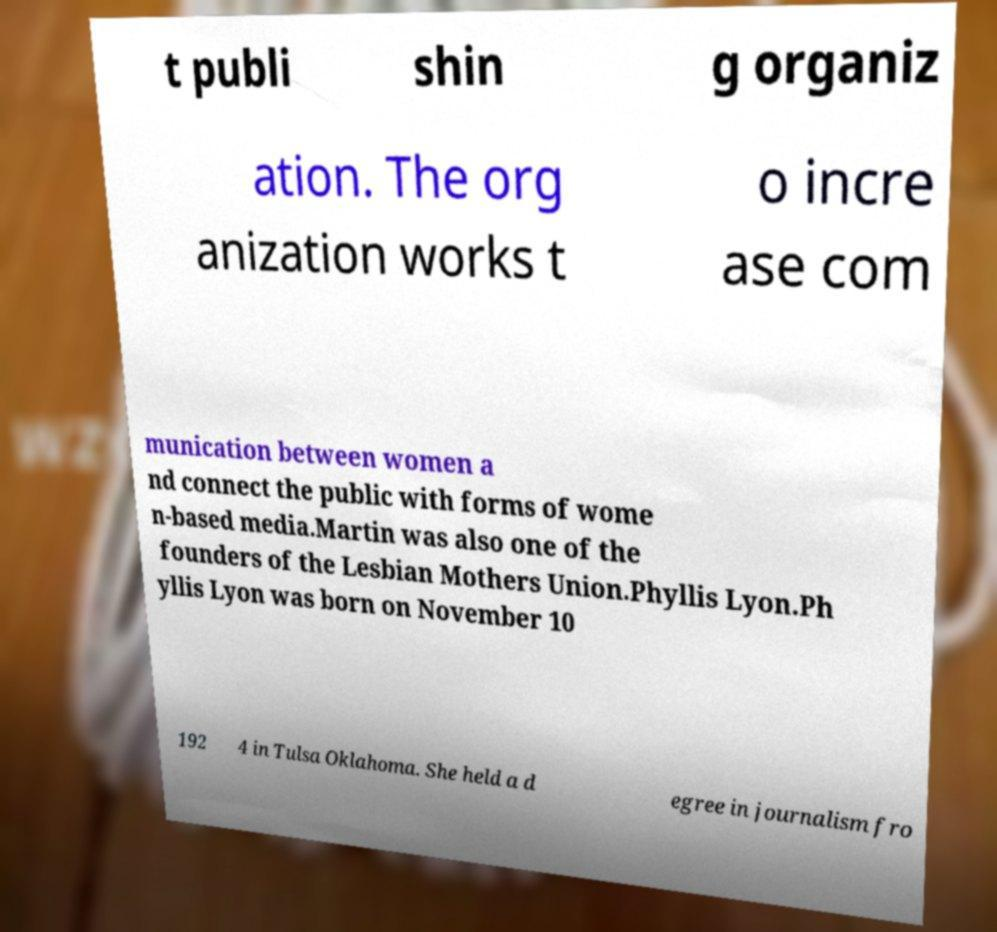There's text embedded in this image that I need extracted. Can you transcribe it verbatim? t publi shin g organiz ation. The org anization works t o incre ase com munication between women a nd connect the public with forms of wome n-based media.Martin was also one of the founders of the Lesbian Mothers Union.Phyllis Lyon.Ph yllis Lyon was born on November 10 192 4 in Tulsa Oklahoma. She held a d egree in journalism fro 